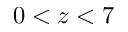Convert formula to latex. <formula><loc_0><loc_0><loc_500><loc_500>0 < z < 7</formula> 